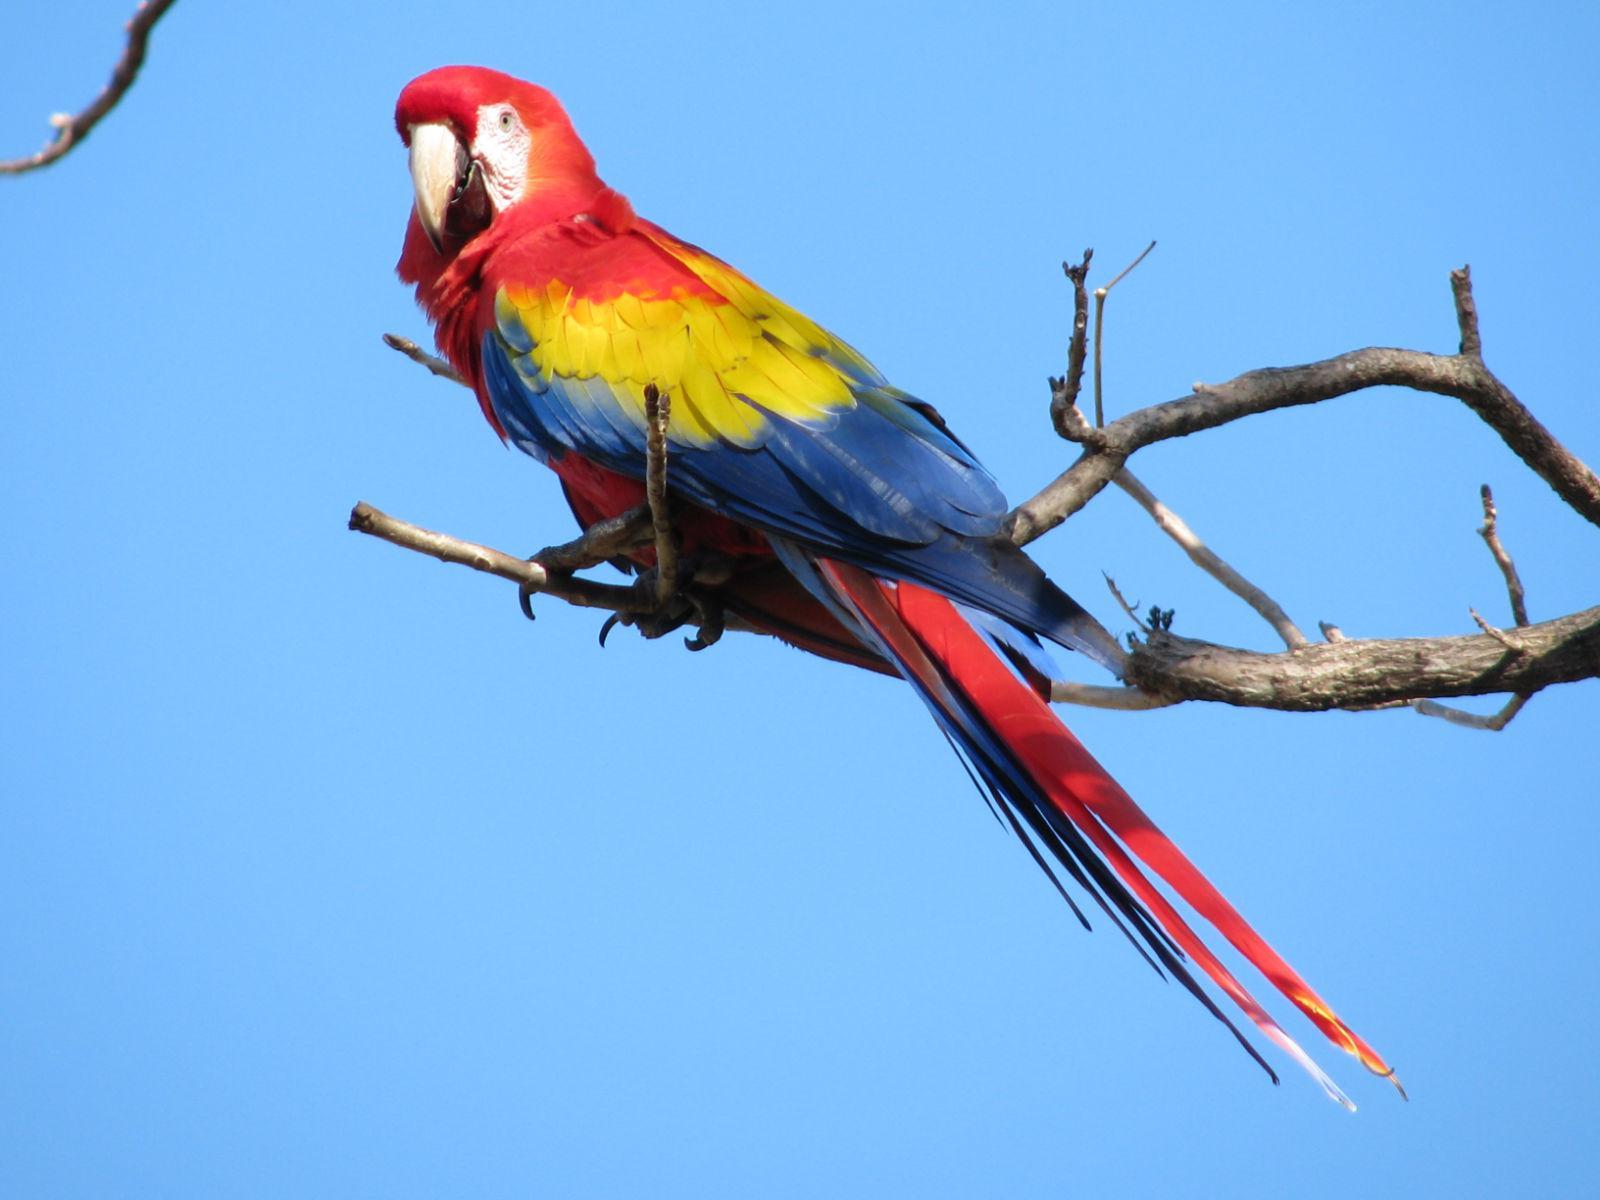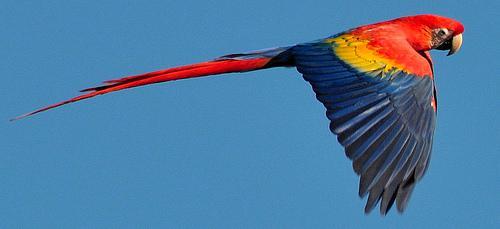The first image is the image on the left, the second image is the image on the right. Given the left and right images, does the statement "3 parrots are in flight in the image pair" hold true? Answer yes or no. No. The first image is the image on the left, the second image is the image on the right. Given the left and right images, does the statement "There is one lone bird flying in one image and two birds flying together in the second." hold true? Answer yes or no. No. 